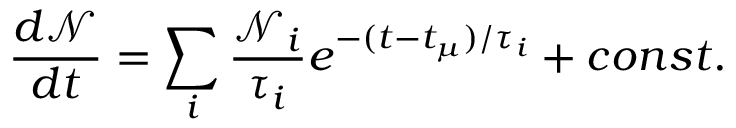<formula> <loc_0><loc_0><loc_500><loc_500>\frac { d \mathcal { N } } { d t } = \sum _ { i } \frac { \mathcal { N } _ { i } } { \tau _ { i } } e ^ { - ( t - t _ { \mu } ) / \tau _ { i } } + c o n s t .</formula> 